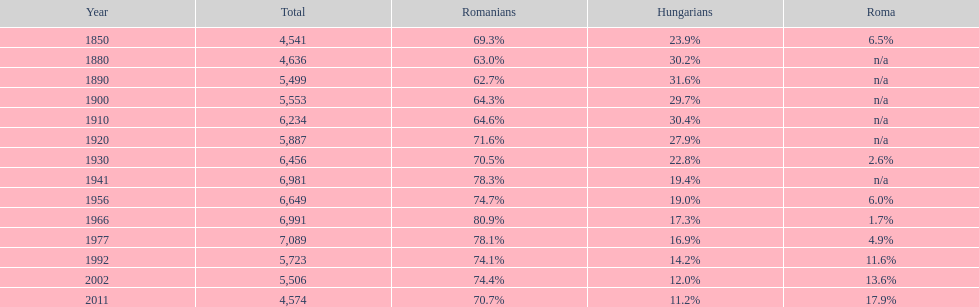What is the number of hungarians in 1850? 23.9%. 